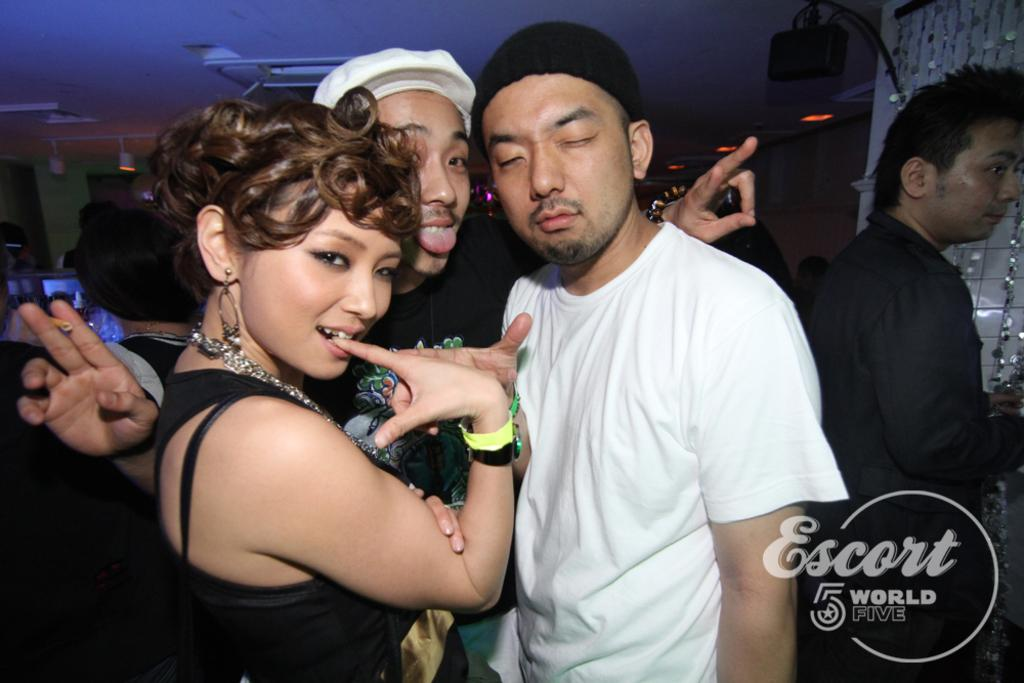Where was the image taken? The image is taken indoors. What can be seen in the middle of the image? There are many people standing in the middle of the image. What surface are the people standing on? The people are standing on the floor. What is visible at the top of the image? There is a ceiling visible at the top of the image. What can be seen in the background of the image? There is a wall in the background of the image. What type of badge is the parent wearing in the image? There is no parent or badge present in the image. What need is being fulfilled by the people standing in the image? The image does not provide information about the needs of the people standing in it. 